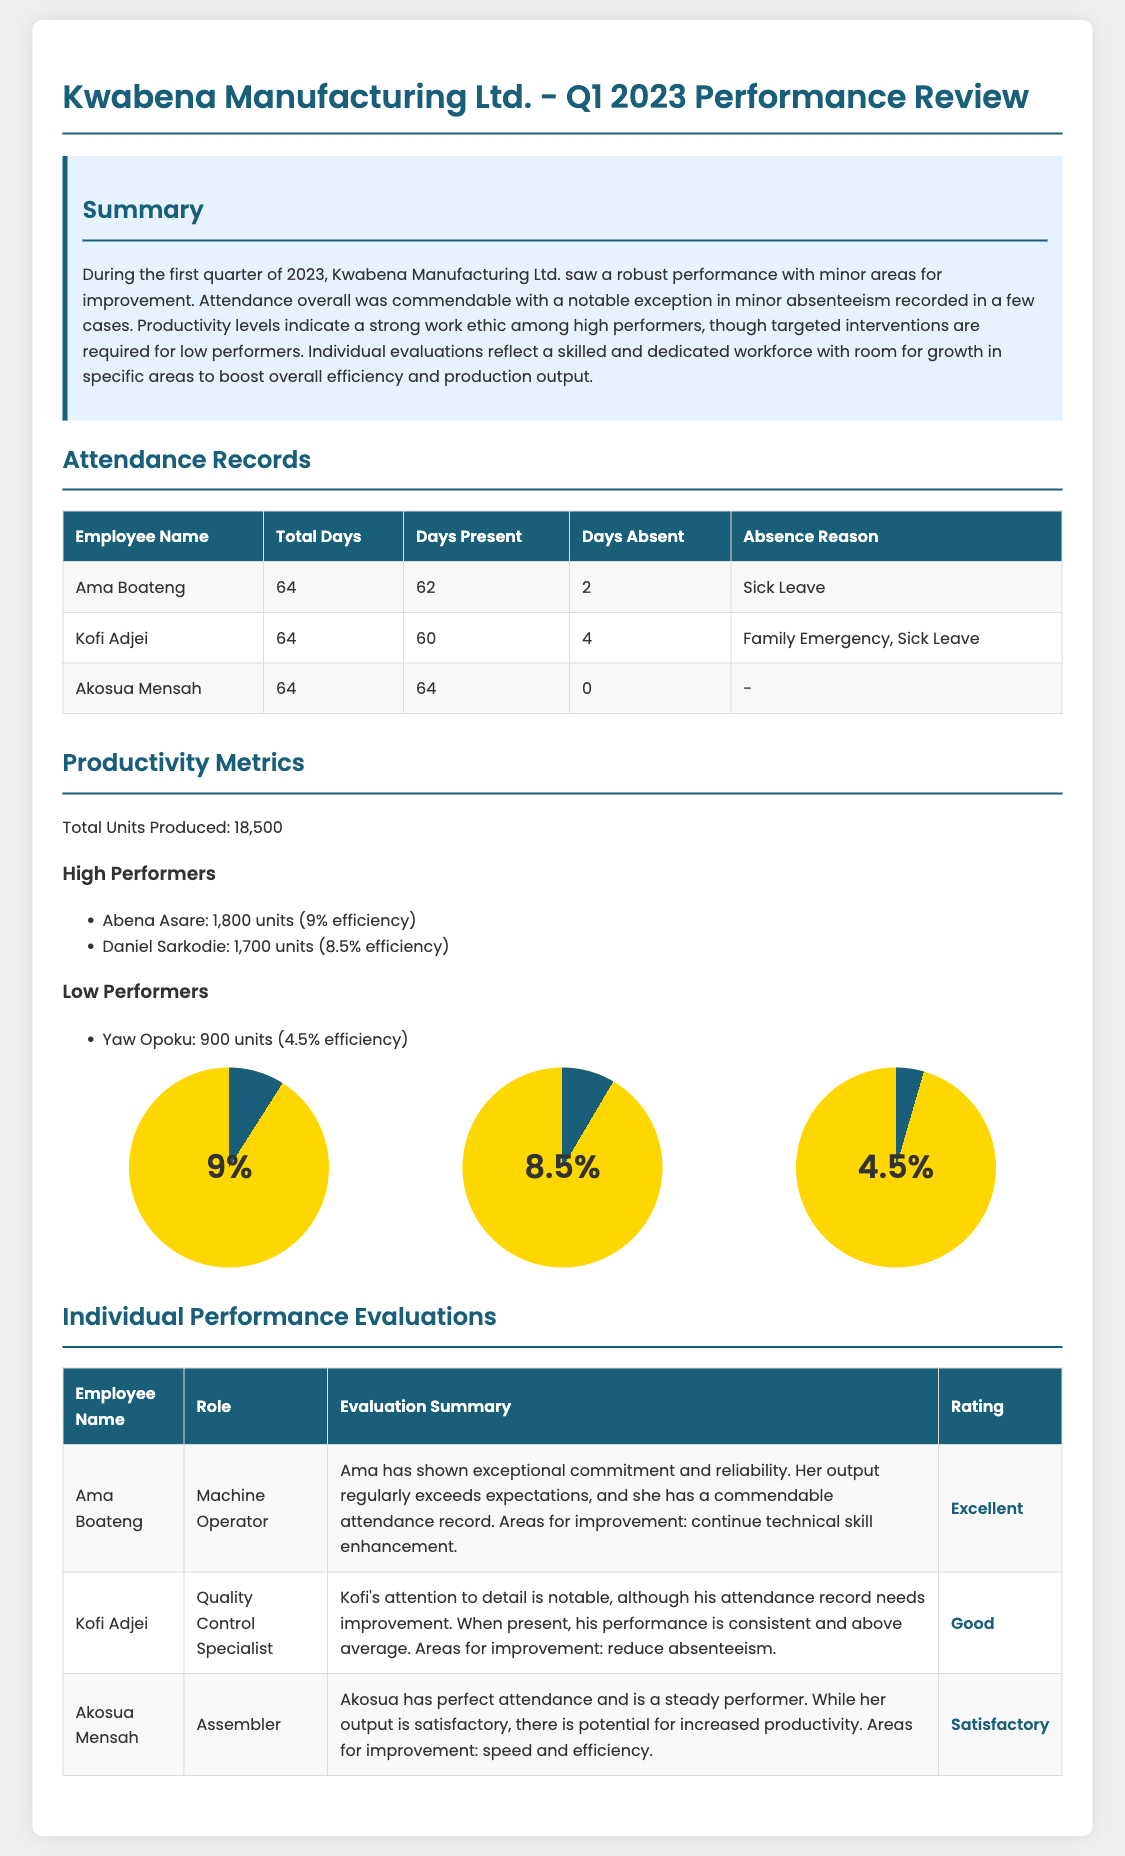What is the total number of days in Q1 2023? Q1 2023 consists of January, February, and March, which typically includes 64 working days.
Answer: 64 How many units did Abena Asare produce? Abena Asare is mentioned as a high performer with a production of 1,800 units.
Answer: 1,800 units What was Ama Boateng's attendance record? Ama Boateng had a total of 64 days, attended 62 days, and was absent for 2 days due to Sick Leave.
Answer: 62 days What rating did Akosua Mensah receive? Akosua Mensah's individual performance evaluation concludes with a rating described as "Satisfactory."
Answer: Satisfactory How many units were produced by low performer Yaw Opoku? The document indicates Yaw Opoku produced 900 units which categorize him as a low performer.
Answer: 900 units What was Kofi Adjei's primary area for improvement? Kofi Adjei's evaluation notes that he needs to reduce absenteeism as an area for improvement.
Answer: Reduce absenteeism What percentage efficiency is attributed to the best performer? The highest efficiency in the document is noted as 9% for Abena Asare.
Answer: 9% What is the total number of units produced overall? The document states that a total of 18,500 units were produced during the first quarter.
Answer: 18,500 units 